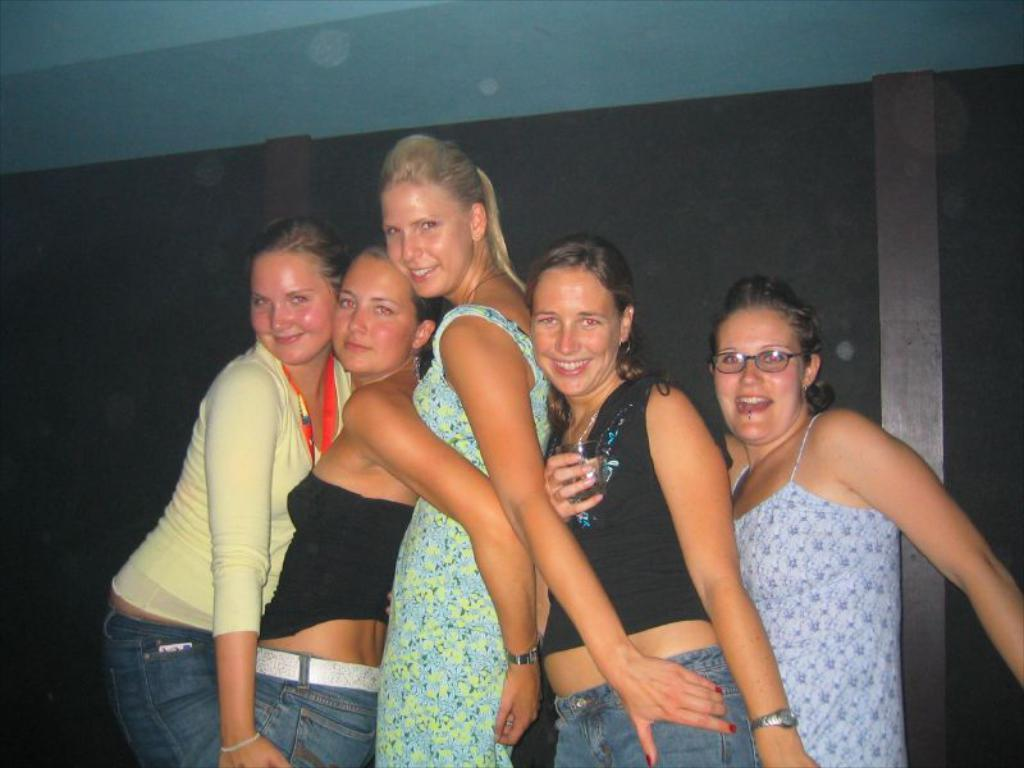Who or what is present in the image? There are people in the image. What is the facial expression of the people in the image? The people are smiling. What can be seen in the background of the image? There is a wall in the background of the image. What type of soda is being served at the organization's event in the image? There is no mention of an organization or event in the image, nor is there any soda present. 